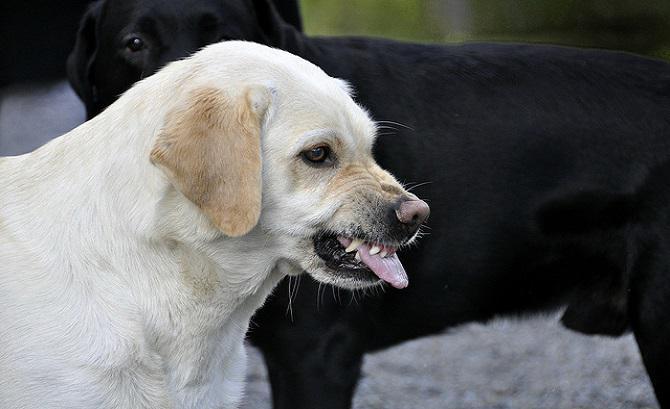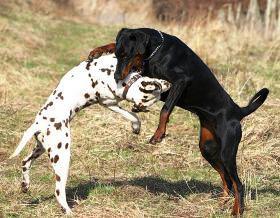The first image is the image on the left, the second image is the image on the right. Evaluate the accuracy of this statement regarding the images: "The right image contains more than one dog, and the left image features a dog with fangs bared in a snarl.". Is it true? Answer yes or no. Yes. The first image is the image on the left, the second image is the image on the right. Assess this claim about the two images: "There is no more than two dogs in the right image.". Correct or not? Answer yes or no. Yes. 